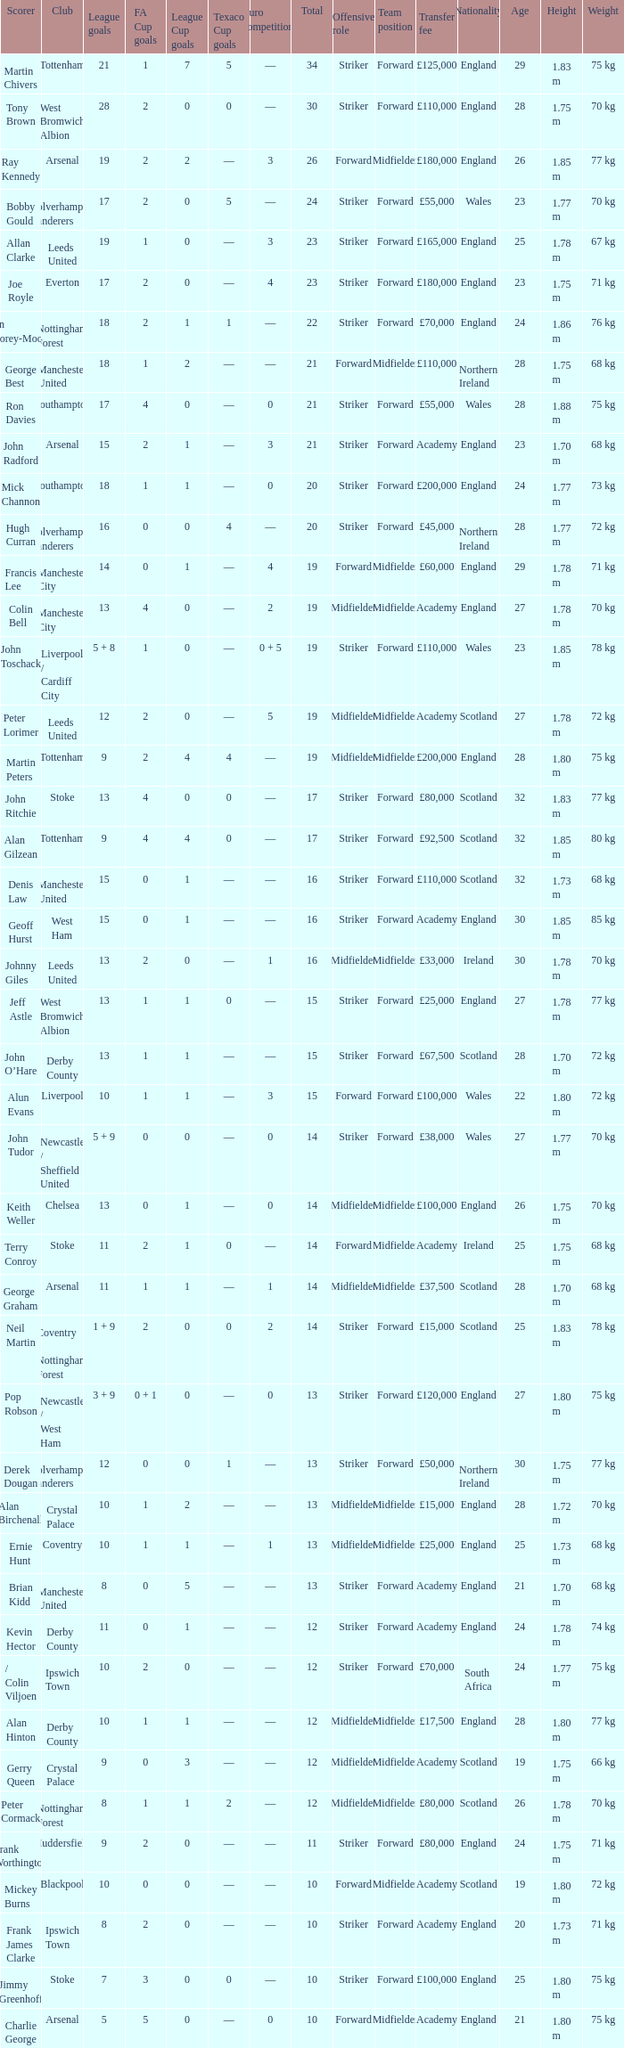What is the total number of Total, when Club is Leeds United, and when League Goals is 13? 1.0. 